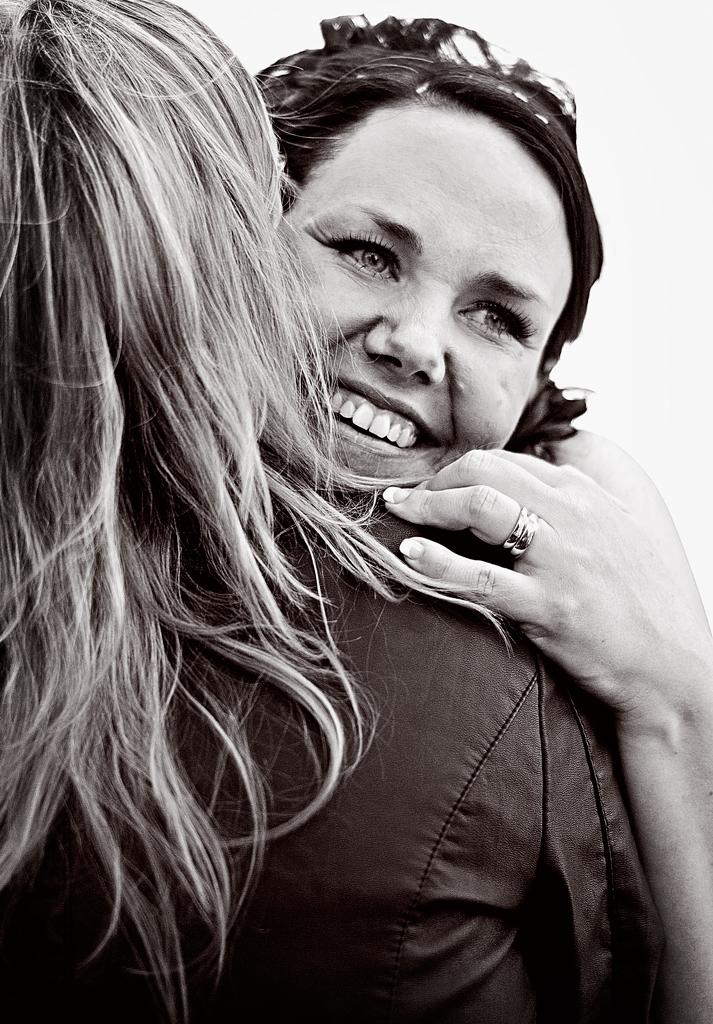What is the color scheme of the image? The image is black and white. How many people are in the image? There are two people in the image. What are the two people doing in the image? The two people are hugging each other. What is the background of the image? There is a white background behind the people. What type of cracker is being served to the people in the image? There is no cracker or serving of food present in the image. What adjustment needs to be made to the image to make it more comfortable for the people? The image does not require any adjustments, as it is a still photograph of two people hugging. 